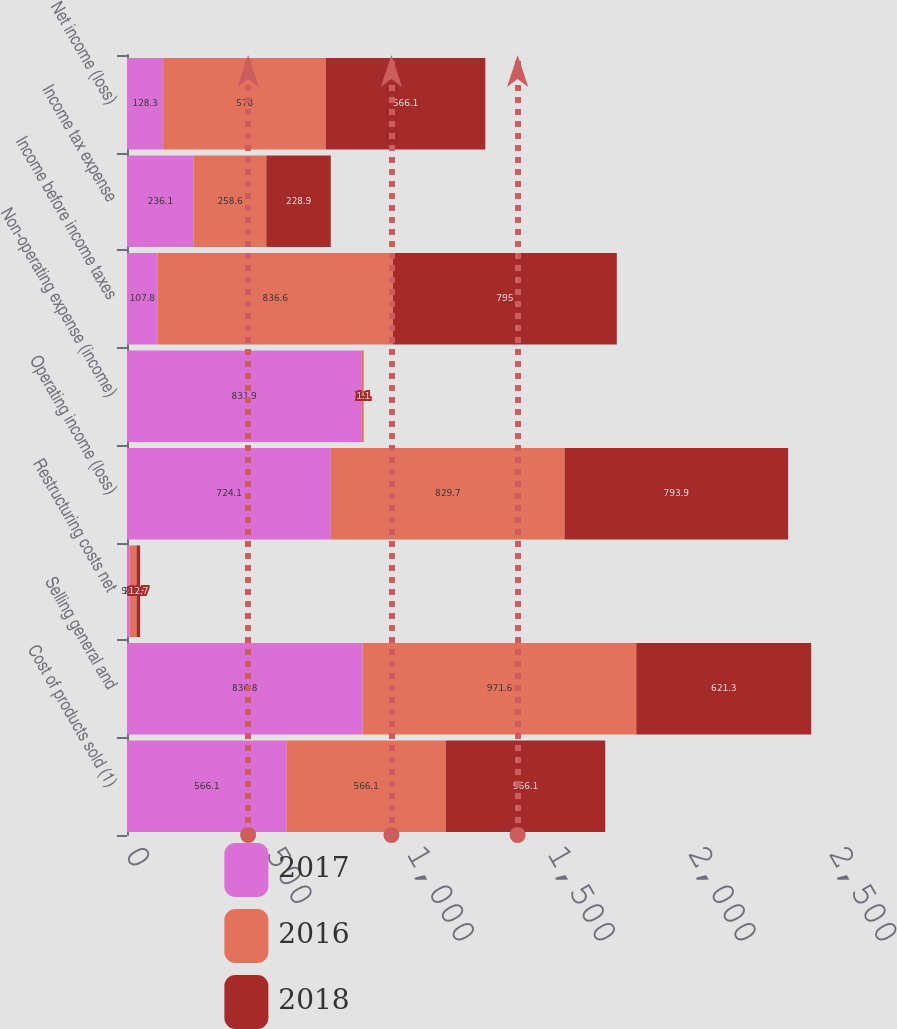<chart> <loc_0><loc_0><loc_500><loc_500><stacked_bar_chart><ecel><fcel>Cost of products sold (1)<fcel>Selling general and<fcel>Restructuring costs net<fcel>Operating income (loss)<fcel>Non-operating expense (income)<fcel>Income before income taxes<fcel>Income tax expense<fcel>Net income (loss)<nl><fcel>2017<fcel>566.1<fcel>836.8<fcel>9.5<fcel>724.1<fcel>831.9<fcel>107.8<fcel>236.1<fcel>128.3<nl><fcel>2016<fcel>566.1<fcel>971.6<fcel>24.3<fcel>829.7<fcel>6.9<fcel>836.6<fcel>258.6<fcel>578<nl><fcel>2018<fcel>566.1<fcel>621.3<fcel>12.7<fcel>793.9<fcel>1.1<fcel>795<fcel>228.9<fcel>566.1<nl></chart> 